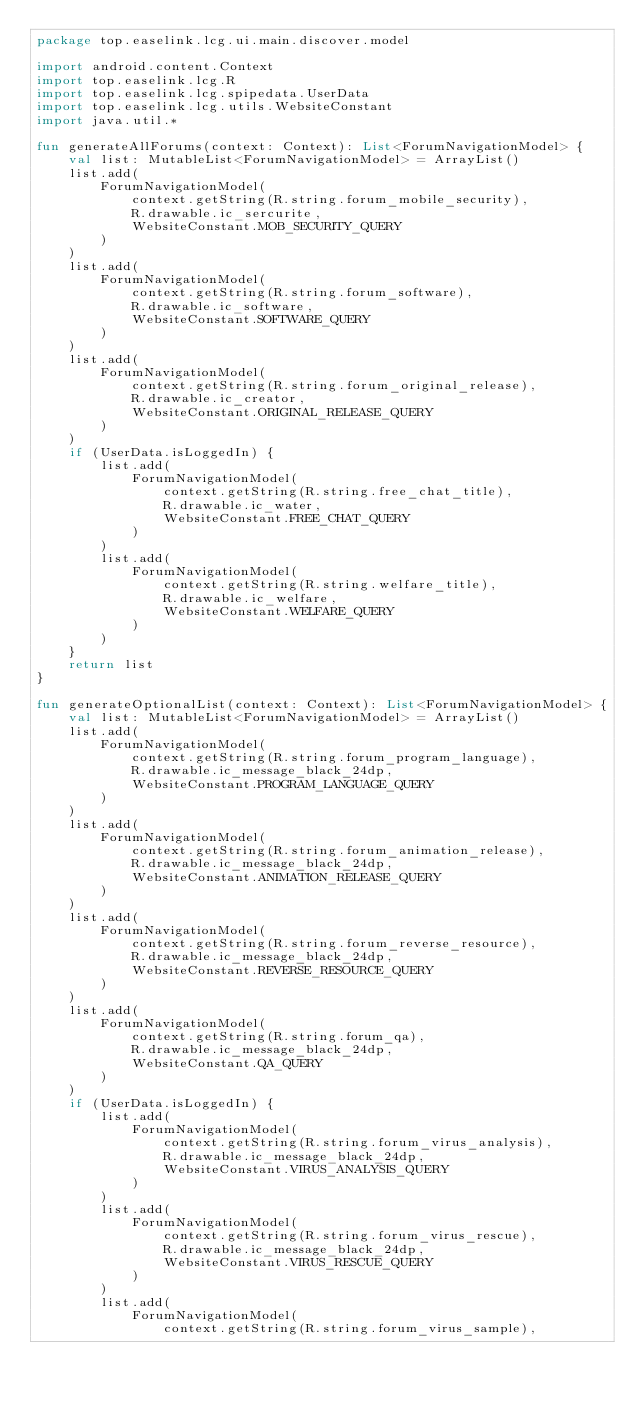<code> <loc_0><loc_0><loc_500><loc_500><_Kotlin_>package top.easelink.lcg.ui.main.discover.model

import android.content.Context
import top.easelink.lcg.R
import top.easelink.lcg.spipedata.UserData
import top.easelink.lcg.utils.WebsiteConstant
import java.util.*

fun generateAllForums(context: Context): List<ForumNavigationModel> {
    val list: MutableList<ForumNavigationModel> = ArrayList()
    list.add(
        ForumNavigationModel(
            context.getString(R.string.forum_mobile_security),
            R.drawable.ic_sercurite,
            WebsiteConstant.MOB_SECURITY_QUERY
        )
    )
    list.add(
        ForumNavigationModel(
            context.getString(R.string.forum_software),
            R.drawable.ic_software,
            WebsiteConstant.SOFTWARE_QUERY
        )
    )
    list.add(
        ForumNavigationModel(
            context.getString(R.string.forum_original_release),
            R.drawable.ic_creator,
            WebsiteConstant.ORIGINAL_RELEASE_QUERY
        )
    )
    if (UserData.isLoggedIn) {
        list.add(
            ForumNavigationModel(
                context.getString(R.string.free_chat_title),
                R.drawable.ic_water,
                WebsiteConstant.FREE_CHAT_QUERY
            )
        )
        list.add(
            ForumNavigationModel(
                context.getString(R.string.welfare_title),
                R.drawable.ic_welfare,
                WebsiteConstant.WELFARE_QUERY
            )
        )
    }
    return list
}

fun generateOptionalList(context: Context): List<ForumNavigationModel> {
    val list: MutableList<ForumNavigationModel> = ArrayList()
    list.add(
        ForumNavigationModel(
            context.getString(R.string.forum_program_language),
            R.drawable.ic_message_black_24dp,
            WebsiteConstant.PROGRAM_LANGUAGE_QUERY
        )
    )
    list.add(
        ForumNavigationModel(
            context.getString(R.string.forum_animation_release),
            R.drawable.ic_message_black_24dp,
            WebsiteConstant.ANIMATION_RELEASE_QUERY
        )
    )
    list.add(
        ForumNavigationModel(
            context.getString(R.string.forum_reverse_resource),
            R.drawable.ic_message_black_24dp,
            WebsiteConstant.REVERSE_RESOURCE_QUERY
        )
    )
    list.add(
        ForumNavigationModel(
            context.getString(R.string.forum_qa),
            R.drawable.ic_message_black_24dp,
            WebsiteConstant.QA_QUERY
        )
    )
    if (UserData.isLoggedIn) {
        list.add(
            ForumNavigationModel(
                context.getString(R.string.forum_virus_analysis),
                R.drawable.ic_message_black_24dp,
                WebsiteConstant.VIRUS_ANALYSIS_QUERY
            )
        )
        list.add(
            ForumNavigationModel(
                context.getString(R.string.forum_virus_rescue),
                R.drawable.ic_message_black_24dp,
                WebsiteConstant.VIRUS_RESCUE_QUERY
            )
        )
        list.add(
            ForumNavigationModel(
                context.getString(R.string.forum_virus_sample),</code> 